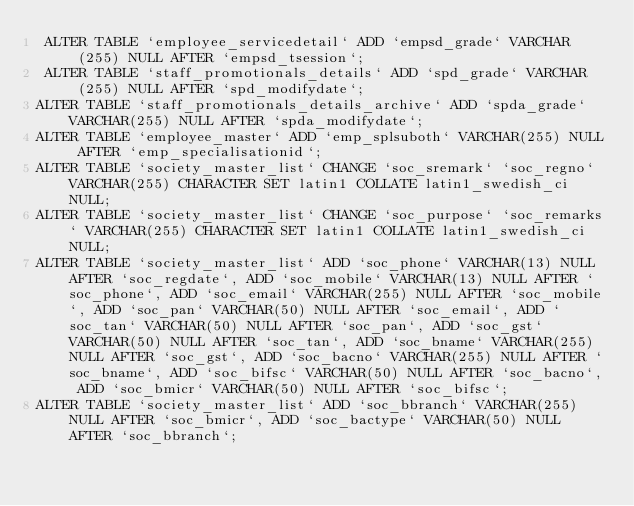Convert code to text. <code><loc_0><loc_0><loc_500><loc_500><_SQL_> ALTER TABLE `employee_servicedetail` ADD `empsd_grade` VARCHAR(255) NULL AFTER `empsd_tsession`;
 ALTER TABLE `staff_promotionals_details` ADD `spd_grade` VARCHAR(255) NULL AFTER `spd_modifydate`;
ALTER TABLE `staff_promotionals_details_archive` ADD `spda_grade` VARCHAR(255) NULL AFTER `spda_modifydate`;
ALTER TABLE `employee_master` ADD `emp_splsuboth` VARCHAR(255) NULL AFTER `emp_specialisationid`;
ALTER TABLE `society_master_list` CHANGE `soc_sremark` `soc_regno` VARCHAR(255) CHARACTER SET latin1 COLLATE latin1_swedish_ci NULL;
ALTER TABLE `society_master_list` CHANGE `soc_purpose` `soc_remarks` VARCHAR(255) CHARACTER SET latin1 COLLATE latin1_swedish_ci NULL;
ALTER TABLE `society_master_list` ADD `soc_phone` VARCHAR(13) NULL AFTER `soc_regdate`, ADD `soc_mobile` VARCHAR(13) NULL AFTER `soc_phone`, ADD `soc_email` VARCHAR(255) NULL AFTER `soc_mobile`, ADD `soc_pan` VARCHAR(50) NULL AFTER `soc_email`, ADD `soc_tan` VARCHAR(50) NULL AFTER `soc_pan`, ADD `soc_gst` VARCHAR(50) NULL AFTER `soc_tan`, ADD `soc_bname` VARCHAR(255) NULL AFTER `soc_gst`, ADD `soc_bacno` VARCHAR(255) NULL AFTER `soc_bname`, ADD `soc_bifsc` VARCHAR(50) NULL AFTER `soc_bacno`, ADD `soc_bmicr` VARCHAR(50) NULL AFTER `soc_bifsc`;
ALTER TABLE `society_master_list` ADD `soc_bbranch` VARCHAR(255) NULL AFTER `soc_bmicr`, ADD `soc_bactype` VARCHAR(50) NULL AFTER `soc_bbranch`;
</code> 